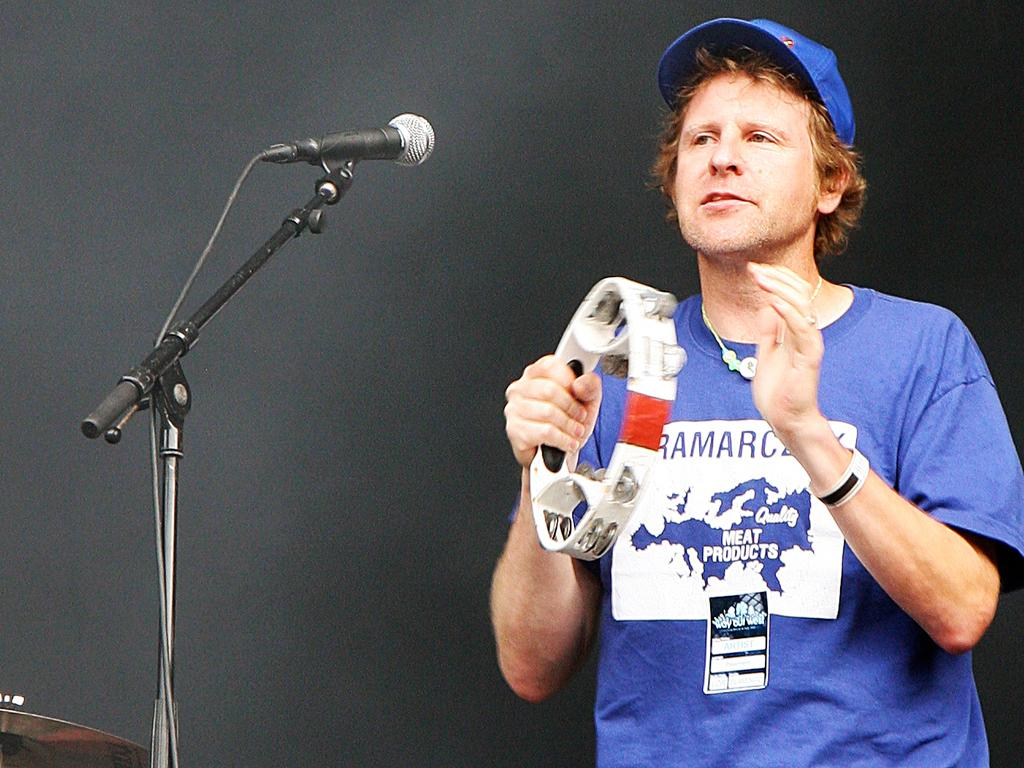What is the main subject of the image? There is a person in the image. What is the person wearing on their head? The person is wearing a cap. What is the person holding in the image? The person is holding a musical instrument. Can you describe any other objects in the image? There is a microphone on the left side of the image. What type of news can be heard from the stamp in the image? There is no stamp present in the image, and therefore no news can be heard from it. 